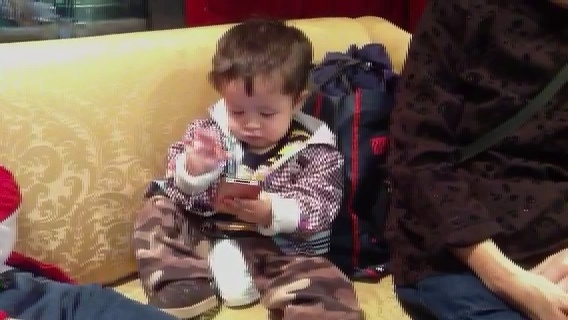Describe the objects in this image and their specific colors. I can see people in gray, black, and beige tones, couch in gray, khaki, and tan tones, people in gray, brown, maroon, and black tones, backpack in gray, black, maroon, and purple tones, and people in gray, darkblue, black, and brown tones in this image. 